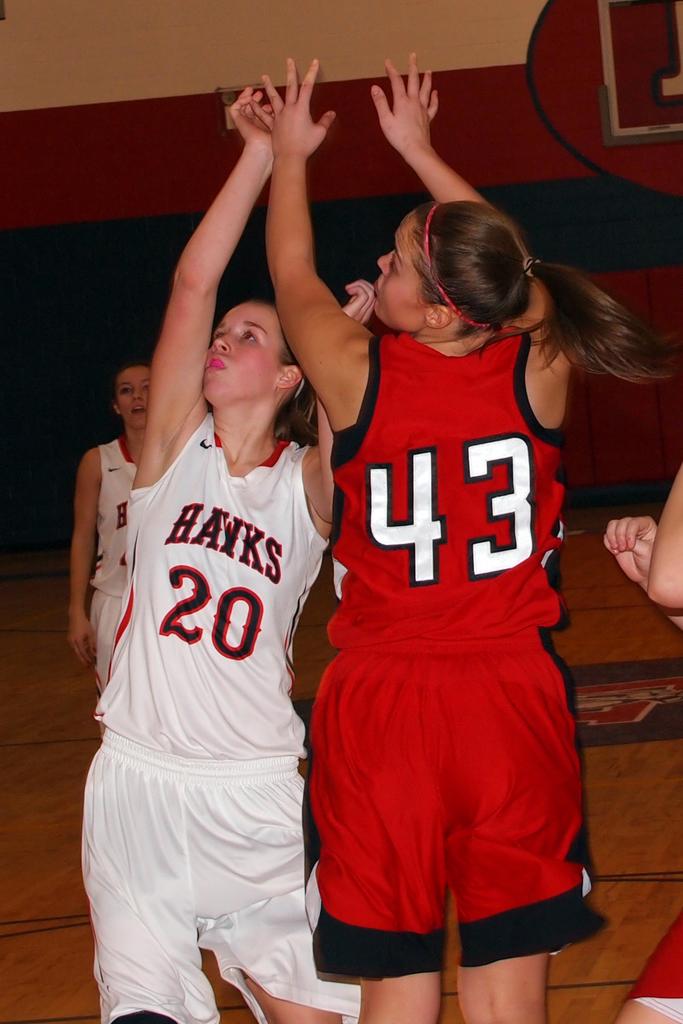What team does number 20 play for?
Ensure brevity in your answer.  Hawks. What is the number of the player in red?
Give a very brief answer. 43. 